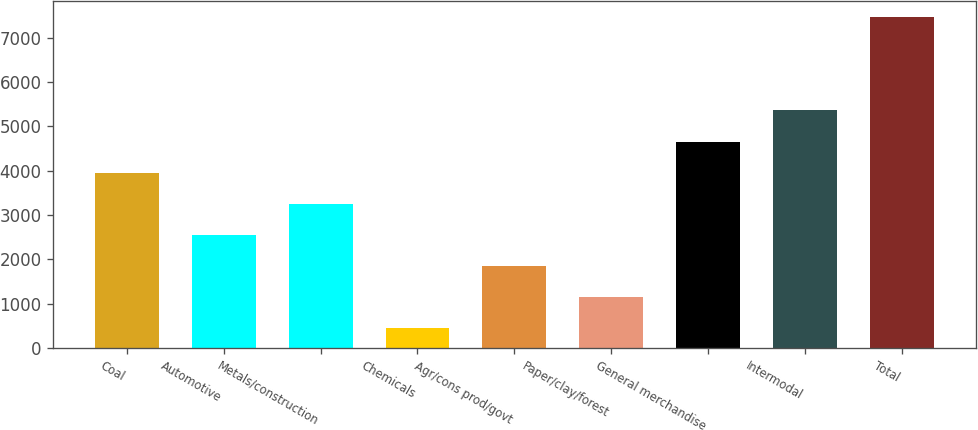Convert chart to OTSL. <chart><loc_0><loc_0><loc_500><loc_500><bar_chart><fcel>Coal<fcel>Automotive<fcel>Metals/construction<fcel>Chemicals<fcel>Agr/cons prod/govt<fcel>Paper/clay/forest<fcel>General merchandise<fcel>Intermodal<fcel>Total<nl><fcel>3956.35<fcel>2553.21<fcel>3254.78<fcel>448.5<fcel>1851.64<fcel>1150.07<fcel>4657.92<fcel>5359.49<fcel>7464.2<nl></chart> 